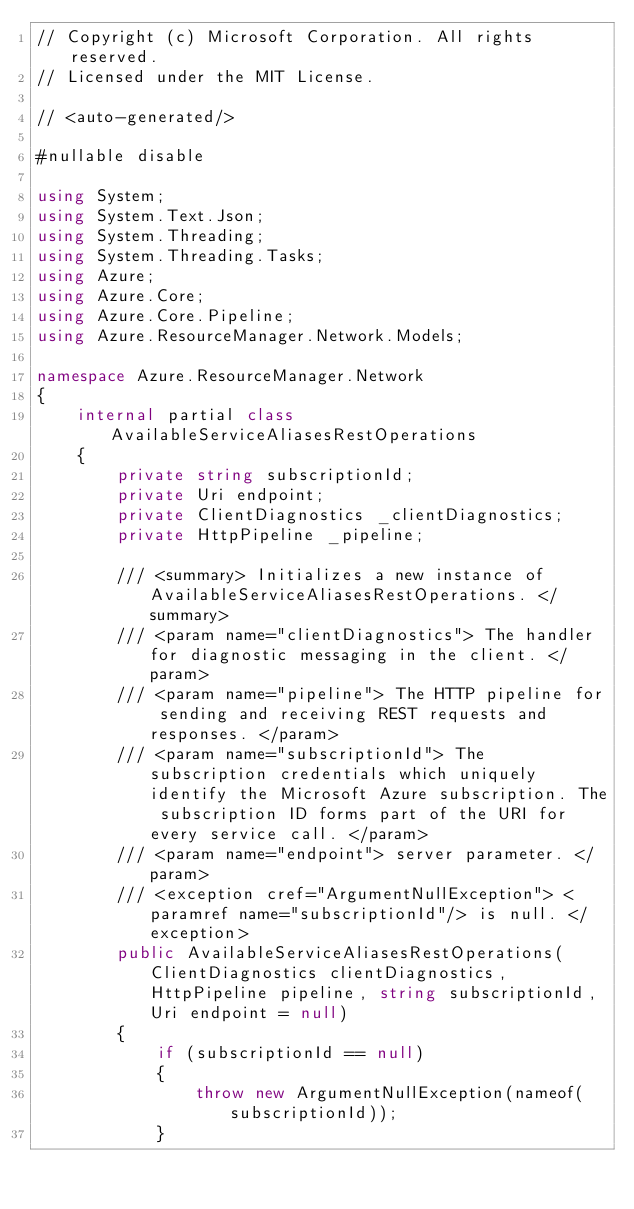<code> <loc_0><loc_0><loc_500><loc_500><_C#_>// Copyright (c) Microsoft Corporation. All rights reserved.
// Licensed under the MIT License.

// <auto-generated/>

#nullable disable

using System;
using System.Text.Json;
using System.Threading;
using System.Threading.Tasks;
using Azure;
using Azure.Core;
using Azure.Core.Pipeline;
using Azure.ResourceManager.Network.Models;

namespace Azure.ResourceManager.Network
{
    internal partial class AvailableServiceAliasesRestOperations
    {
        private string subscriptionId;
        private Uri endpoint;
        private ClientDiagnostics _clientDiagnostics;
        private HttpPipeline _pipeline;

        /// <summary> Initializes a new instance of AvailableServiceAliasesRestOperations. </summary>
        /// <param name="clientDiagnostics"> The handler for diagnostic messaging in the client. </param>
        /// <param name="pipeline"> The HTTP pipeline for sending and receiving REST requests and responses. </param>
        /// <param name="subscriptionId"> The subscription credentials which uniquely identify the Microsoft Azure subscription. The subscription ID forms part of the URI for every service call. </param>
        /// <param name="endpoint"> server parameter. </param>
        /// <exception cref="ArgumentNullException"> <paramref name="subscriptionId"/> is null. </exception>
        public AvailableServiceAliasesRestOperations(ClientDiagnostics clientDiagnostics, HttpPipeline pipeline, string subscriptionId, Uri endpoint = null)
        {
            if (subscriptionId == null)
            {
                throw new ArgumentNullException(nameof(subscriptionId));
            }</code> 